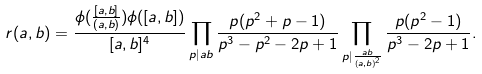Convert formula to latex. <formula><loc_0><loc_0><loc_500><loc_500>r ( a , b ) = \frac { \phi ( \frac { [ a , b ] } { ( a , b ) } ) \phi ( [ a , b ] ) } { [ a , b ] ^ { 4 } } \prod _ { p | a b } \frac { p ( p ^ { 2 } + p - 1 ) } { p ^ { 3 } - p ^ { 2 } - 2 p + 1 } \prod _ { p | \frac { a b } { ( a , b ) ^ { 2 } } } \frac { p ( p ^ { 2 } - 1 ) } { p ^ { 3 } - 2 p + 1 } .</formula> 